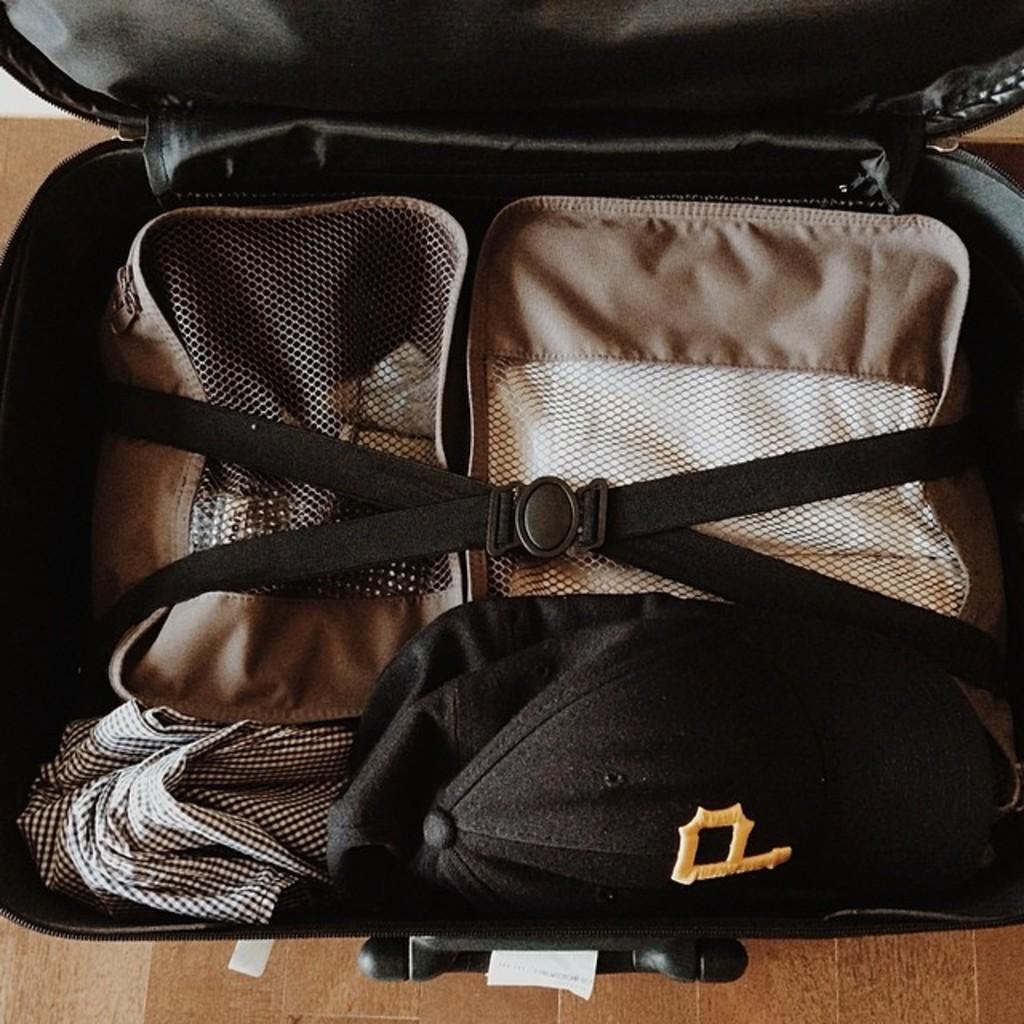Please provide a concise description of this image. In this image there is a black luggage placed on the ground. In the baggage there are two couches and a belt attached to them. 